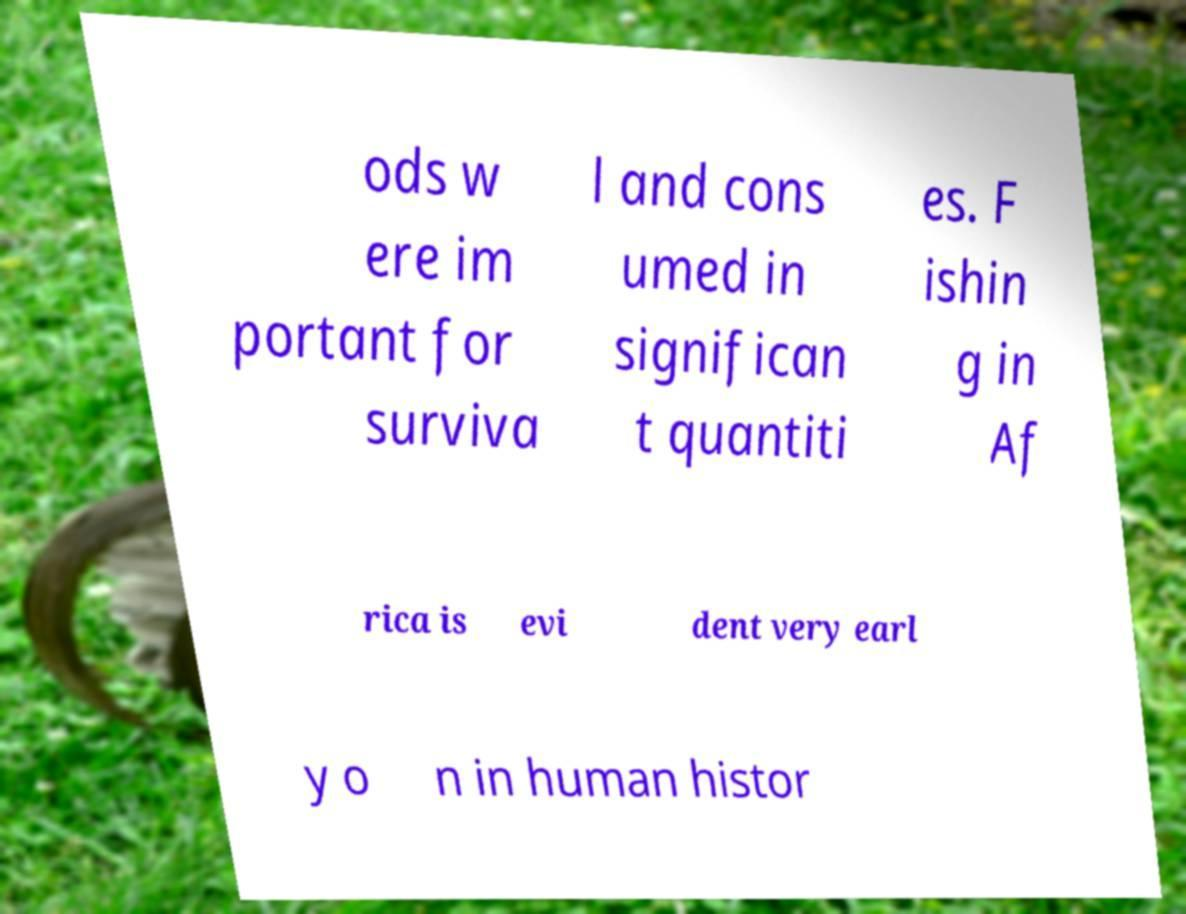Could you assist in decoding the text presented in this image and type it out clearly? ods w ere im portant for surviva l and cons umed in significan t quantiti es. F ishin g in Af rica is evi dent very earl y o n in human histor 